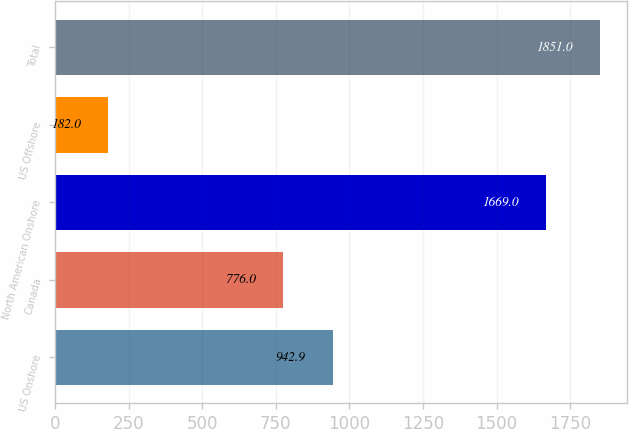Convert chart. <chart><loc_0><loc_0><loc_500><loc_500><bar_chart><fcel>US Onshore<fcel>Canada<fcel>North American Onshore<fcel>US Offshore<fcel>Total<nl><fcel>942.9<fcel>776<fcel>1669<fcel>182<fcel>1851<nl></chart> 